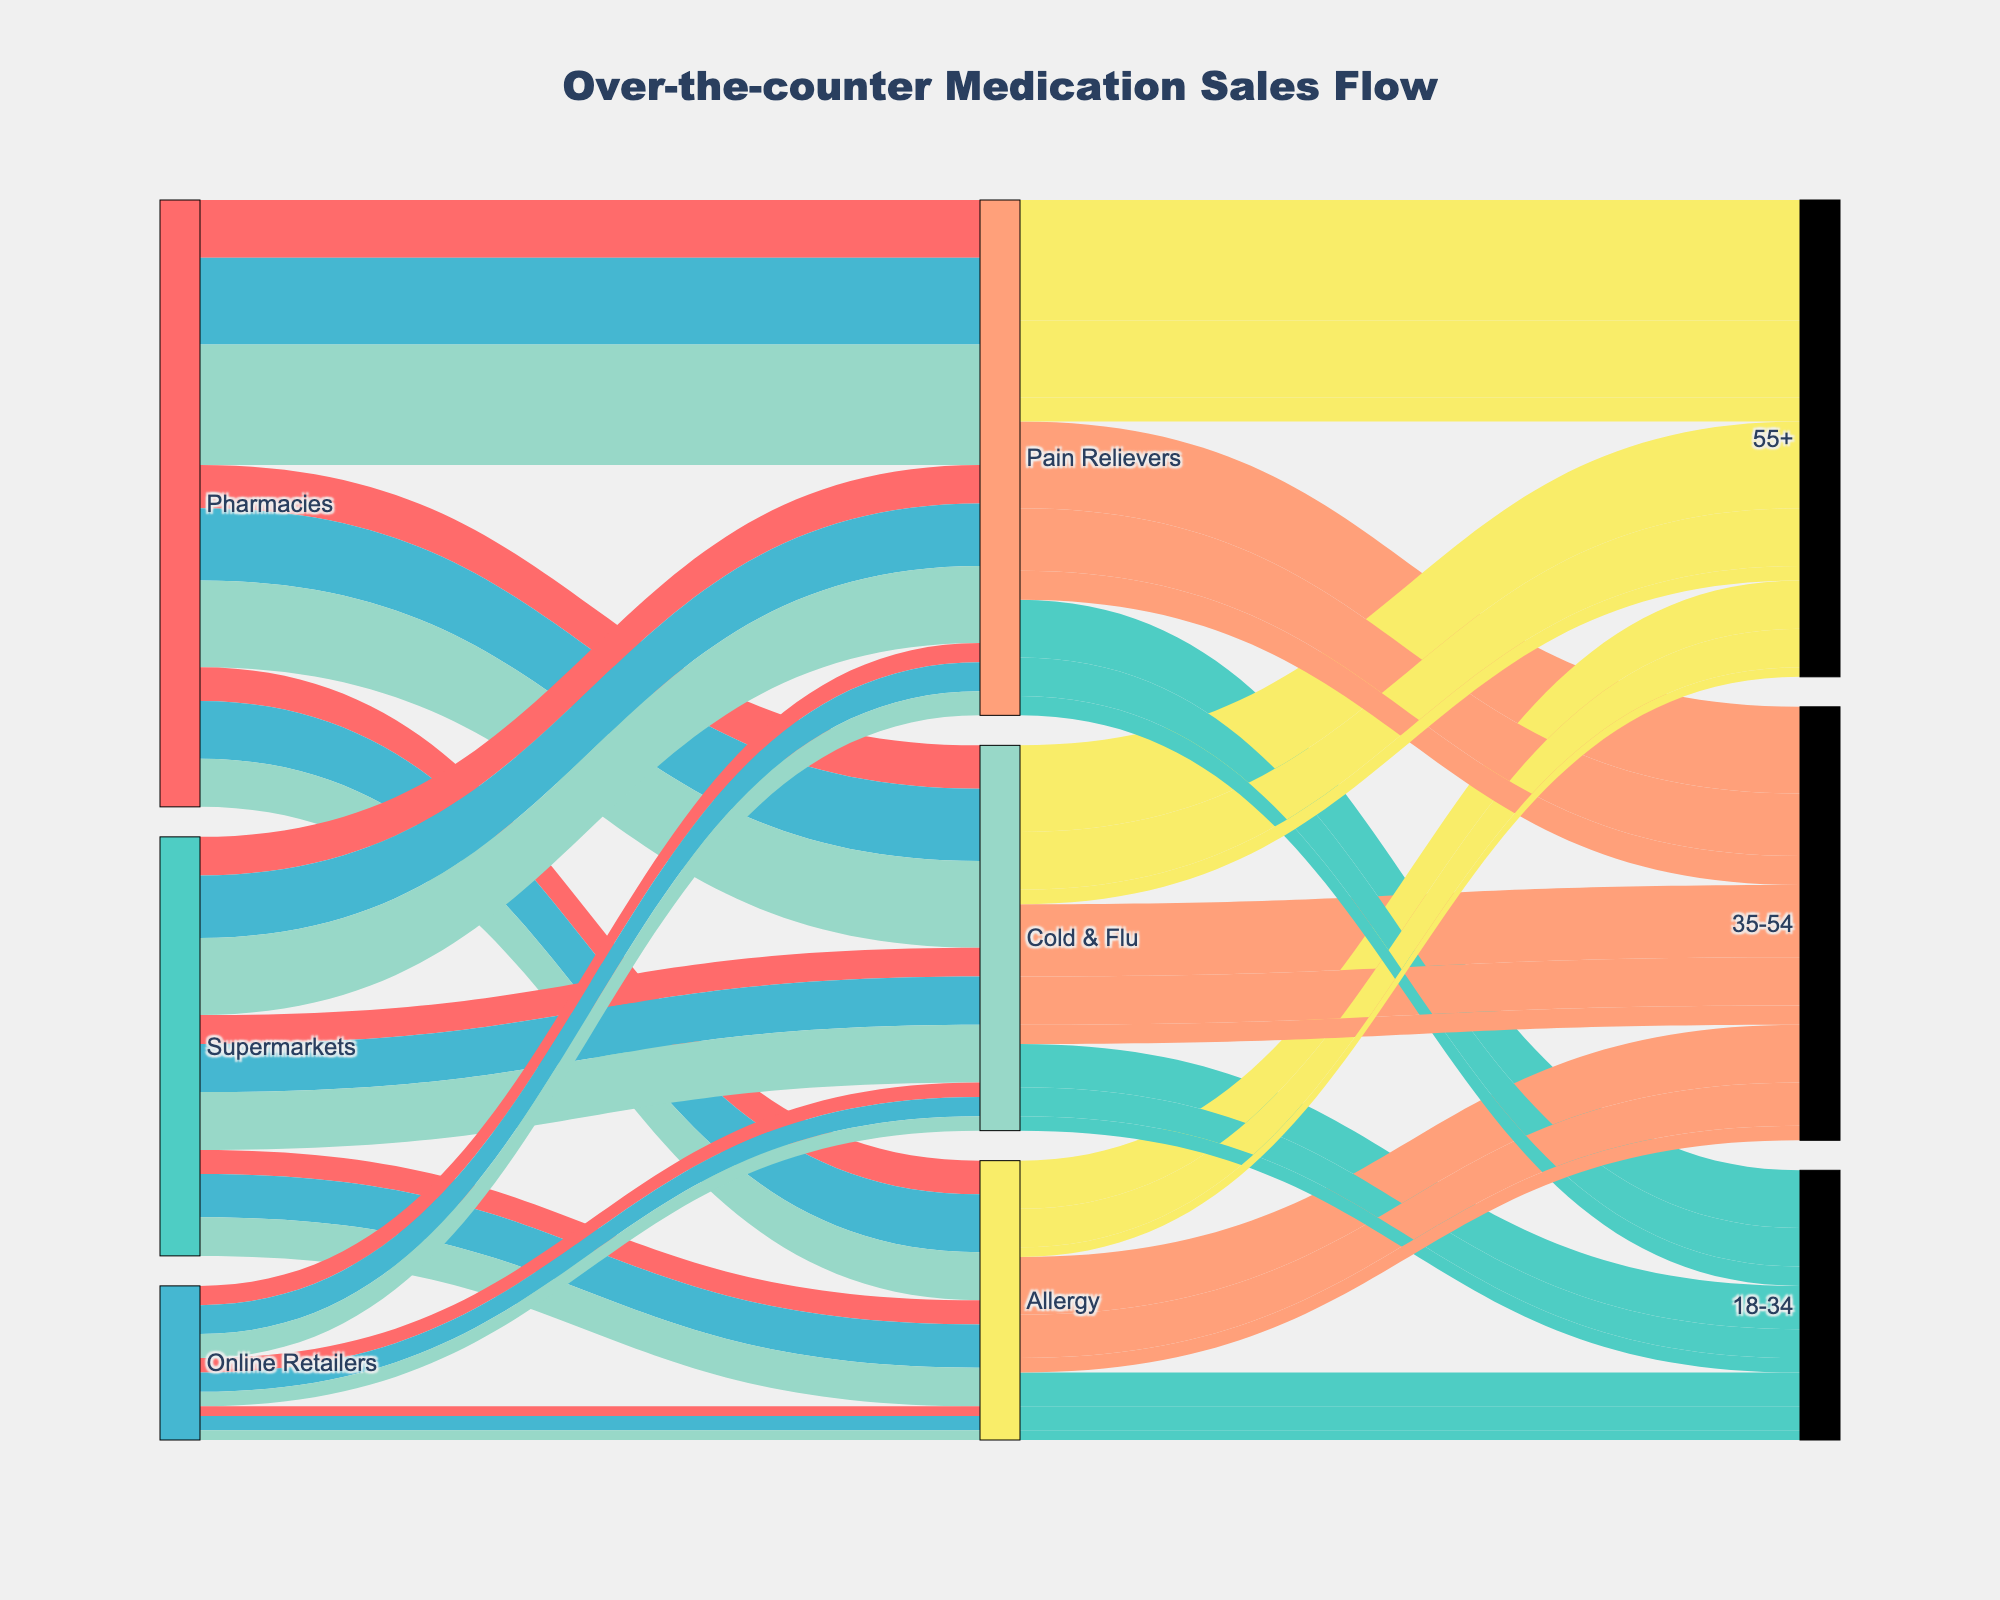What is the title of the figure? The title is typically displayed at the top of the figure in larger and bold text. Here, it is centered at the top.
Answer: Over-the-counter Medication Sales Flow Which sources contribute to the sales data shown in the diagram? The sources are listed as unique nodes on the left side of the diagram. They represent the starting points of the flow in the Sankey diagram.
Answer: Pharmacies, Supermarkets, Online Retailers Which age group has the highest sales volume for Pain Relievers through Pharmacies? Follow the flow from the Pharmacies node to the Pain Relievers node, then trace it to the age group nodes. The width of the band represents the sales volume.
Answer: 55+ What is the combined sales volume for the 18-34 age group across all categories and sources? Sum up the volumes from all flows ending at the 18-34 age group nodes from each source and category combination.
Answer: 4,800,000 Which source has the smallest share of sales for Cold & Flu medication? Compare the width of the flows for Cold & Flu medication from each source. The source with the smallest flow has the smallest share.
Answer: Online Retailers What is the difference in sales volume of Allergy medication between supermarkets and online retailers for the 35-54 age group? Find the flows from Supermarkets and Online Retailers to Allergy to the 35-54 age group, then subtract the sales volume of Online Retailers from that of Supermarkets.
Answer: 600,000 Which category of medication has the highest total sales volume across all age groups and sources? For each medication category, sum the sales volumes flowing into all age groups from all sources, then compare these sums to find the highest.
Answer: Pain Relievers How do the sales volumes of Cold & Flu medication for the 18-34 and 55+ age groups compare when purchased from pharmacies? Trace and compare the flows from the Pharmacies node to the Cold & Flu node and then to the 18-34 and 55+ age group nodes. The width of the bands can be visually compared to see which is higher.
Answer: 55+ is higher For which age group does Online Retailers have the highest sales volume in any category? Analyze each flow from Online Retailers to the various age group nodes, across all categories, and identify where the flow is the thickest.
Answer: 35-54 What is the total sales volume for Cold & Flu medications across all sources and age groups? Sum the sales volumes of all flows leading to the Cold & Flu category node from all sources and into all age groups.
Answer: 6,500,000 